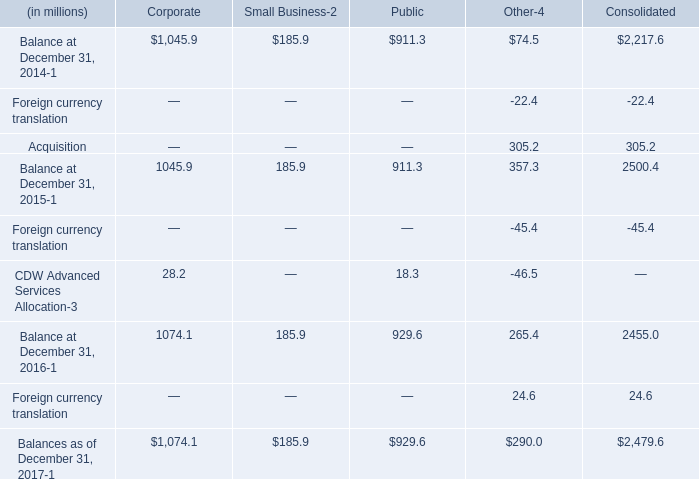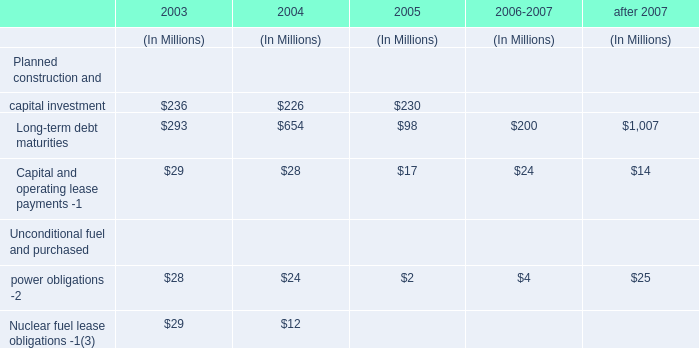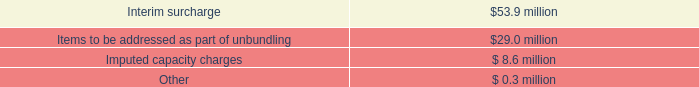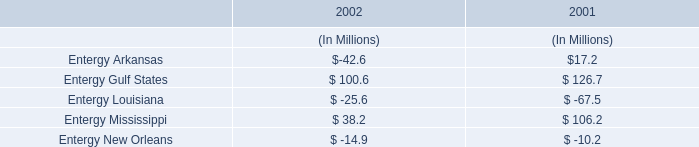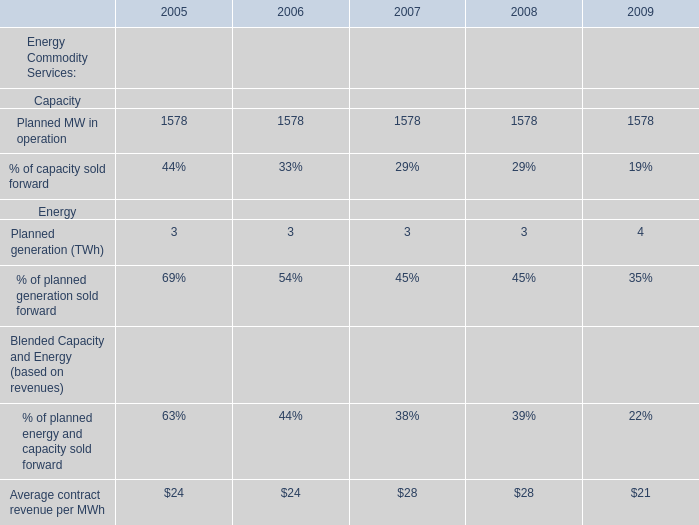What is the average amount of Planned MW in operation of 2005, and Balance at December 31, 2015 of Corporate ? 
Computations: ((1578.0 + 1045.9) / 2)
Answer: 1311.95. 